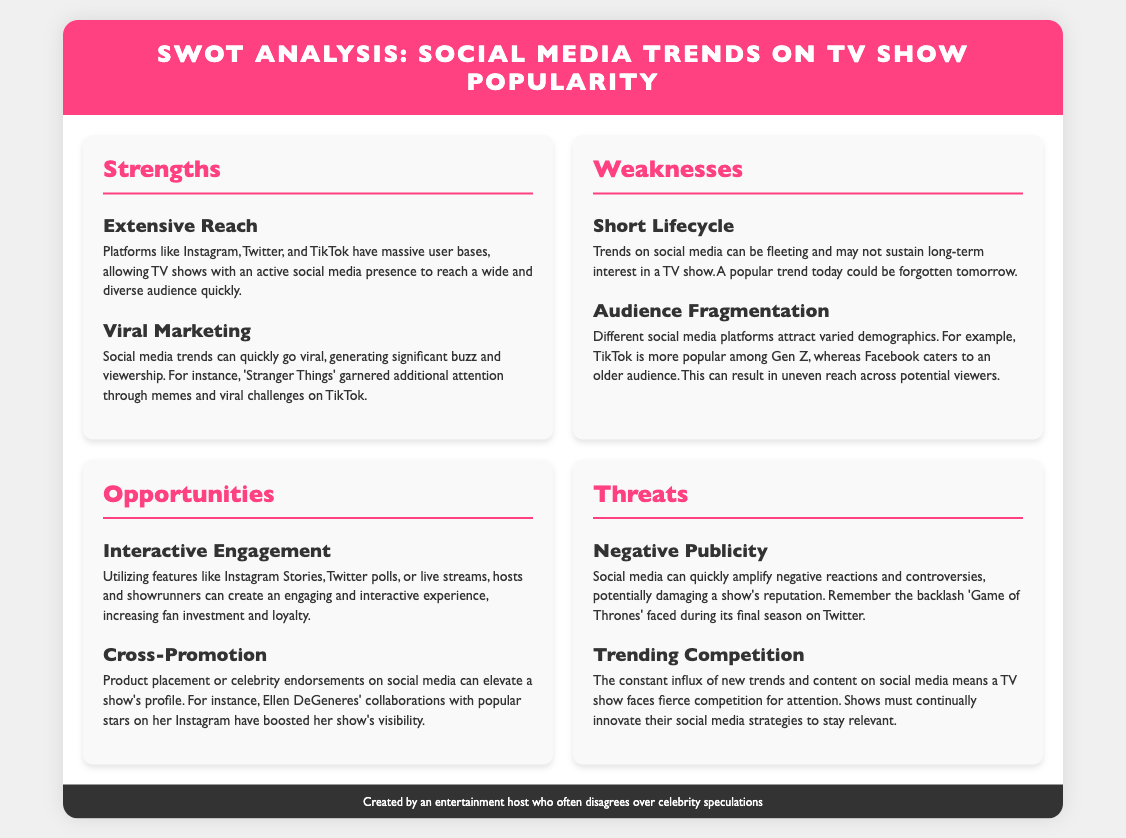What is the title of the document? The title of the document is indicated in the header section.
Answer: SWOT Analysis: Social Media Trends on TV Show Popularity How many strengths are listed in the document? The document contains a section titled "Strengths" with two items listed.
Answer: 2 What is one example of viral marketing mentioned? The document specifically mentions 'Stranger Things' as an example of viral marketing generated through memes and challenges.
Answer: 'Stranger Things' What is a key opportunity for TV shows in social media mentioned? One of the opportunities highlighted is "Interactive Engagement," which involves utilizing social media features for fan interaction.
Answer: Interactive Engagement Which platform is noted for attracting a younger audience? The document mentions TikTok as being more popular among Gen Z in terms of audience demographic.
Answer: TikTok What threat is associated with negative publicity? The document cites that negative publicity can quickly escalate on social media, potentially harming a show's reputation, as seen with 'Game of Thrones.'
Answer: Negative Publicity What is indicated as a significant challenge for TV shows on social media? The document states that there is a constant influx of new trends and content, presenting fierce competition for a TV show's attention.
Answer: Trending Competition What kind of engagement can create fan loyalty? The document suggests that "Interactive Engagement" through features like polls and live streams can increase fan investment and loyalty.
Answer: Interactive Engagement What is highlighted as a weakness regarding trends? The document notes that trends on social media can have a "Short Lifecycle," meaning they may not sustain long-term interest.
Answer: Short Lifecycle 